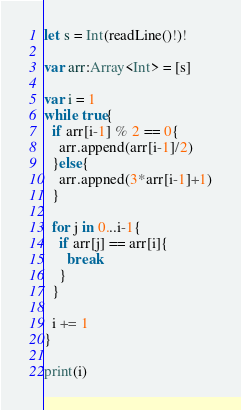<code> <loc_0><loc_0><loc_500><loc_500><_Swift_>let s = Int(readLine()!)!

var arr:Array<Int> = [s]

var i = 1
while true{
  if arr[i-1] % 2 == 0{
    arr.append(arr[i-1]/2)
  }else{
    arr.appned(3*arr[i-1]+1)
  }
  
  for j in 0...i-1{
    if arr[j] == arr[i]{
      break
    }
  }
  
  i += 1
}

print(i)</code> 